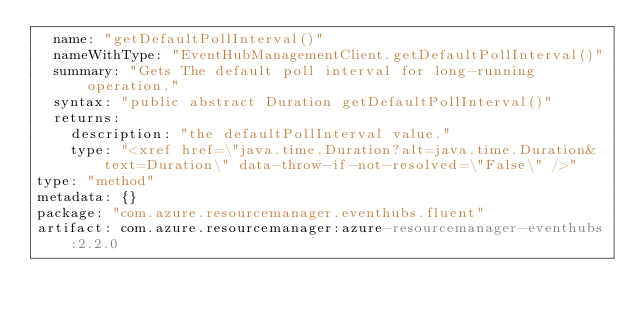<code> <loc_0><loc_0><loc_500><loc_500><_YAML_>  name: "getDefaultPollInterval()"
  nameWithType: "EventHubManagementClient.getDefaultPollInterval()"
  summary: "Gets The default poll interval for long-running operation."
  syntax: "public abstract Duration getDefaultPollInterval()"
  returns:
    description: "the defaultPollInterval value."
    type: "<xref href=\"java.time.Duration?alt=java.time.Duration&text=Duration\" data-throw-if-not-resolved=\"False\" />"
type: "method"
metadata: {}
package: "com.azure.resourcemanager.eventhubs.fluent"
artifact: com.azure.resourcemanager:azure-resourcemanager-eventhubs:2.2.0
</code> 